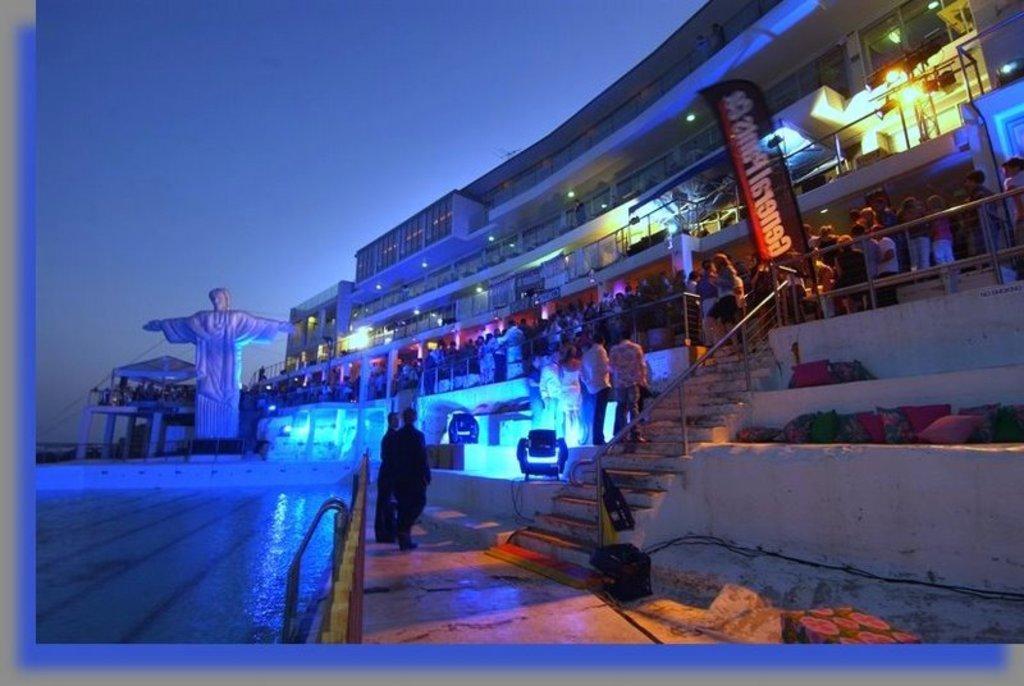Could you give a brief overview of what you see in this image? This image consists of many persons. On the right, there is a building. In the front, we can see the steps along with a railing. On the left, there is a statue. At the bottom, there is a floor. 